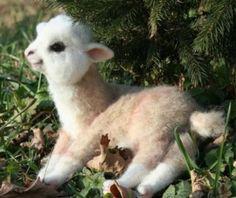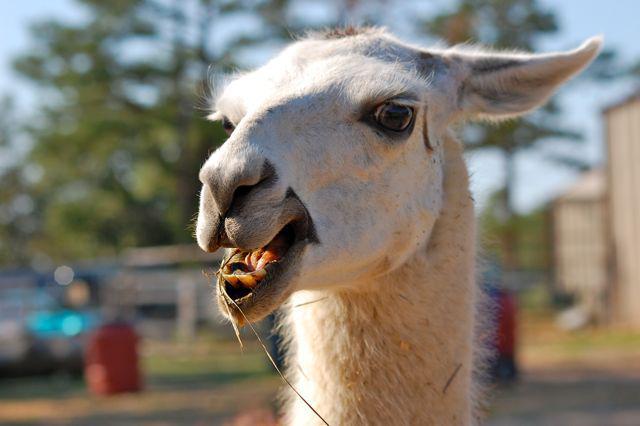The first image is the image on the left, the second image is the image on the right. Examine the images to the left and right. Is the description "One image shows one dark-eyed white llama, which faces forward and has a partly open mouth revealing several yellow teeth." accurate? Answer yes or no. Yes. The first image is the image on the left, the second image is the image on the right. Assess this claim about the two images: "There are two llamas in total.". Correct or not? Answer yes or no. Yes. 